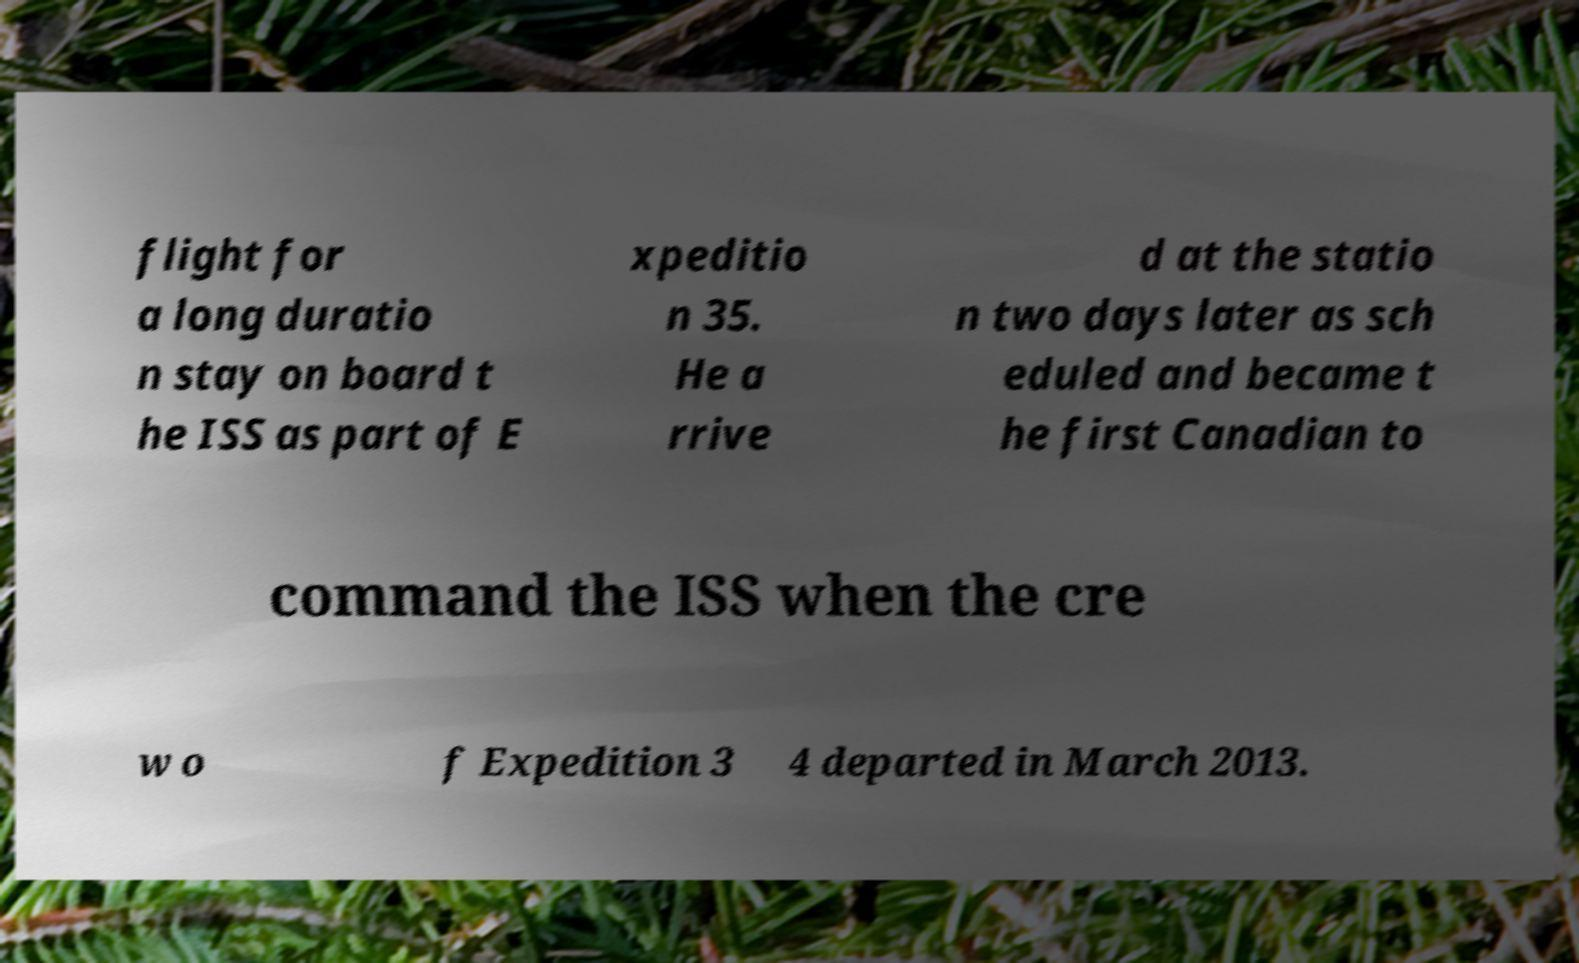What messages or text are displayed in this image? I need them in a readable, typed format. flight for a long duratio n stay on board t he ISS as part of E xpeditio n 35. He a rrive d at the statio n two days later as sch eduled and became t he first Canadian to command the ISS when the cre w o f Expedition 3 4 departed in March 2013. 